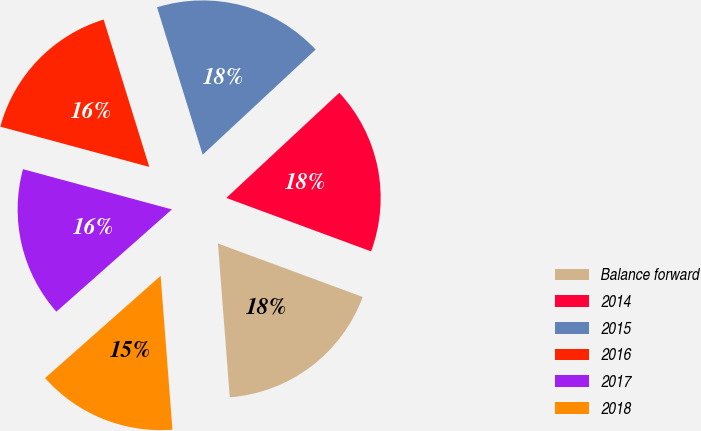<chart> <loc_0><loc_0><loc_500><loc_500><pie_chart><fcel>Balance forward<fcel>2014<fcel>2015<fcel>2016<fcel>2017<fcel>2018<nl><fcel>18.15%<fcel>17.56%<fcel>17.85%<fcel>16.02%<fcel>15.73%<fcel>14.69%<nl></chart> 